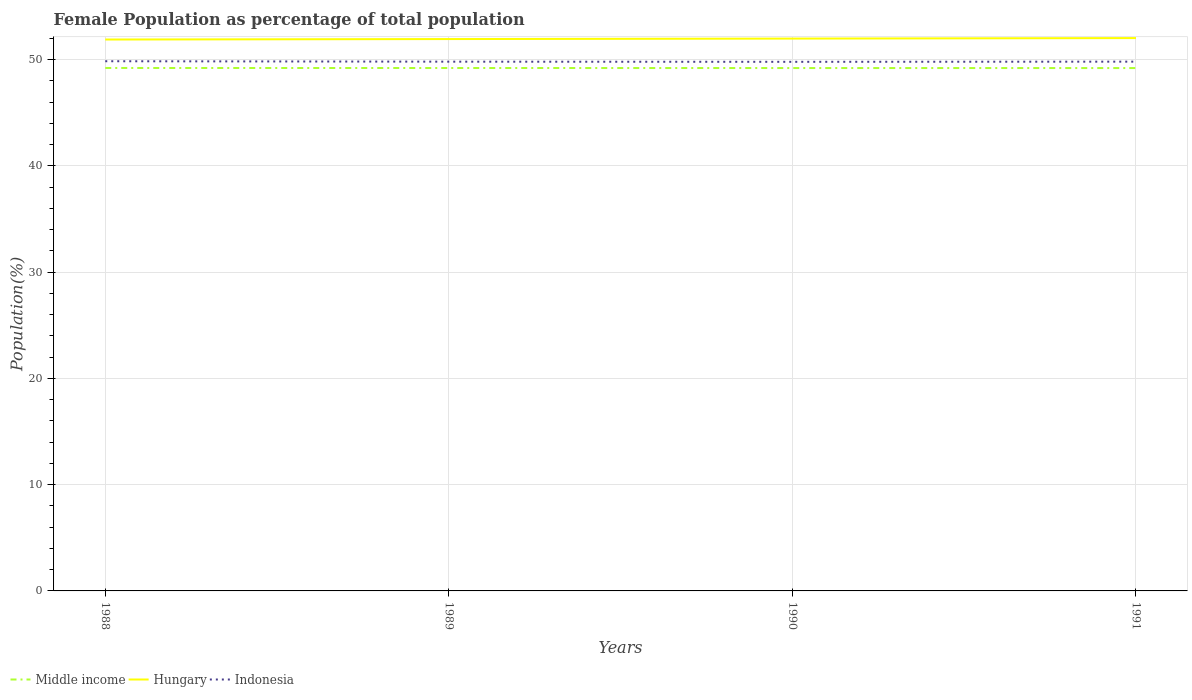Across all years, what is the maximum female population in in Indonesia?
Provide a succinct answer. 49.78. In which year was the female population in in Indonesia maximum?
Your answer should be very brief. 1990. What is the total female population in in Hungary in the graph?
Your response must be concise. -0.04. What is the difference between the highest and the second highest female population in in Middle income?
Your answer should be compact. 0.01. Is the female population in in Middle income strictly greater than the female population in in Indonesia over the years?
Your answer should be very brief. Yes. How many years are there in the graph?
Your answer should be very brief. 4. What is the difference between two consecutive major ticks on the Y-axis?
Keep it short and to the point. 10. Does the graph contain any zero values?
Offer a very short reply. No. What is the title of the graph?
Your response must be concise. Female Population as percentage of total population. Does "Belarus" appear as one of the legend labels in the graph?
Offer a very short reply. No. What is the label or title of the X-axis?
Ensure brevity in your answer.  Years. What is the label or title of the Y-axis?
Offer a very short reply. Population(%). What is the Population(%) of Middle income in 1988?
Provide a succinct answer. 49.2. What is the Population(%) in Hungary in 1988?
Offer a very short reply. 51.88. What is the Population(%) in Indonesia in 1988?
Make the answer very short. 49.84. What is the Population(%) in Middle income in 1989?
Offer a terse response. 49.2. What is the Population(%) in Hungary in 1989?
Offer a very short reply. 51.92. What is the Population(%) of Indonesia in 1989?
Provide a succinct answer. 49.8. What is the Population(%) of Middle income in 1990?
Provide a succinct answer. 49.2. What is the Population(%) in Hungary in 1990?
Keep it short and to the point. 51.97. What is the Population(%) of Indonesia in 1990?
Provide a short and direct response. 49.78. What is the Population(%) of Middle income in 1991?
Your answer should be very brief. 49.19. What is the Population(%) of Hungary in 1991?
Your answer should be very brief. 52.02. What is the Population(%) in Indonesia in 1991?
Give a very brief answer. 49.8. Across all years, what is the maximum Population(%) in Middle income?
Ensure brevity in your answer.  49.2. Across all years, what is the maximum Population(%) of Hungary?
Your answer should be compact. 52.02. Across all years, what is the maximum Population(%) in Indonesia?
Offer a terse response. 49.84. Across all years, what is the minimum Population(%) of Middle income?
Keep it short and to the point. 49.19. Across all years, what is the minimum Population(%) of Hungary?
Ensure brevity in your answer.  51.88. Across all years, what is the minimum Population(%) in Indonesia?
Make the answer very short. 49.78. What is the total Population(%) in Middle income in the graph?
Keep it short and to the point. 196.79. What is the total Population(%) of Hungary in the graph?
Keep it short and to the point. 207.78. What is the total Population(%) of Indonesia in the graph?
Your answer should be very brief. 199.21. What is the difference between the Population(%) of Middle income in 1988 and that in 1989?
Offer a very short reply. 0. What is the difference between the Population(%) of Hungary in 1988 and that in 1989?
Provide a short and direct response. -0.04. What is the difference between the Population(%) in Indonesia in 1988 and that in 1989?
Your answer should be compact. 0.04. What is the difference between the Population(%) in Middle income in 1988 and that in 1990?
Your answer should be very brief. 0.01. What is the difference between the Population(%) of Hungary in 1988 and that in 1990?
Ensure brevity in your answer.  -0.09. What is the difference between the Population(%) of Indonesia in 1988 and that in 1990?
Provide a succinct answer. 0.06. What is the difference between the Population(%) of Middle income in 1988 and that in 1991?
Offer a very short reply. 0.01. What is the difference between the Population(%) of Hungary in 1988 and that in 1991?
Your answer should be compact. -0.13. What is the difference between the Population(%) in Indonesia in 1988 and that in 1991?
Give a very brief answer. 0.04. What is the difference between the Population(%) of Middle income in 1989 and that in 1990?
Provide a succinct answer. 0. What is the difference between the Population(%) in Hungary in 1989 and that in 1990?
Ensure brevity in your answer.  -0.04. What is the difference between the Population(%) of Indonesia in 1989 and that in 1990?
Provide a succinct answer. 0.01. What is the difference between the Population(%) in Middle income in 1989 and that in 1991?
Make the answer very short. 0. What is the difference between the Population(%) in Hungary in 1989 and that in 1991?
Offer a terse response. -0.09. What is the difference between the Population(%) in Indonesia in 1989 and that in 1991?
Your answer should be compact. -0. What is the difference between the Population(%) of Middle income in 1990 and that in 1991?
Offer a terse response. 0. What is the difference between the Population(%) in Hungary in 1990 and that in 1991?
Your response must be concise. -0.05. What is the difference between the Population(%) in Indonesia in 1990 and that in 1991?
Make the answer very short. -0.02. What is the difference between the Population(%) of Middle income in 1988 and the Population(%) of Hungary in 1989?
Keep it short and to the point. -2.72. What is the difference between the Population(%) in Middle income in 1988 and the Population(%) in Indonesia in 1989?
Ensure brevity in your answer.  -0.59. What is the difference between the Population(%) in Hungary in 1988 and the Population(%) in Indonesia in 1989?
Your response must be concise. 2.09. What is the difference between the Population(%) of Middle income in 1988 and the Population(%) of Hungary in 1990?
Ensure brevity in your answer.  -2.76. What is the difference between the Population(%) of Middle income in 1988 and the Population(%) of Indonesia in 1990?
Provide a short and direct response. -0.58. What is the difference between the Population(%) of Hungary in 1988 and the Population(%) of Indonesia in 1990?
Your answer should be very brief. 2.1. What is the difference between the Population(%) in Middle income in 1988 and the Population(%) in Hungary in 1991?
Your answer should be compact. -2.81. What is the difference between the Population(%) of Middle income in 1988 and the Population(%) of Indonesia in 1991?
Your answer should be very brief. -0.6. What is the difference between the Population(%) of Hungary in 1988 and the Population(%) of Indonesia in 1991?
Offer a terse response. 2.08. What is the difference between the Population(%) of Middle income in 1989 and the Population(%) of Hungary in 1990?
Your response must be concise. -2.77. What is the difference between the Population(%) of Middle income in 1989 and the Population(%) of Indonesia in 1990?
Your answer should be very brief. -0.58. What is the difference between the Population(%) of Hungary in 1989 and the Population(%) of Indonesia in 1990?
Offer a very short reply. 2.14. What is the difference between the Population(%) in Middle income in 1989 and the Population(%) in Hungary in 1991?
Provide a succinct answer. -2.82. What is the difference between the Population(%) of Middle income in 1989 and the Population(%) of Indonesia in 1991?
Your answer should be very brief. -0.6. What is the difference between the Population(%) in Hungary in 1989 and the Population(%) in Indonesia in 1991?
Provide a short and direct response. 2.12. What is the difference between the Population(%) of Middle income in 1990 and the Population(%) of Hungary in 1991?
Offer a terse response. -2.82. What is the difference between the Population(%) of Middle income in 1990 and the Population(%) of Indonesia in 1991?
Ensure brevity in your answer.  -0.6. What is the difference between the Population(%) of Hungary in 1990 and the Population(%) of Indonesia in 1991?
Keep it short and to the point. 2.17. What is the average Population(%) in Middle income per year?
Offer a very short reply. 49.2. What is the average Population(%) in Hungary per year?
Ensure brevity in your answer.  51.95. What is the average Population(%) of Indonesia per year?
Provide a succinct answer. 49.8. In the year 1988, what is the difference between the Population(%) in Middle income and Population(%) in Hungary?
Your response must be concise. -2.68. In the year 1988, what is the difference between the Population(%) in Middle income and Population(%) in Indonesia?
Offer a terse response. -0.64. In the year 1988, what is the difference between the Population(%) of Hungary and Population(%) of Indonesia?
Your answer should be very brief. 2.04. In the year 1989, what is the difference between the Population(%) in Middle income and Population(%) in Hungary?
Your answer should be very brief. -2.72. In the year 1989, what is the difference between the Population(%) in Middle income and Population(%) in Indonesia?
Your answer should be compact. -0.6. In the year 1989, what is the difference between the Population(%) of Hungary and Population(%) of Indonesia?
Provide a succinct answer. 2.13. In the year 1990, what is the difference between the Population(%) of Middle income and Population(%) of Hungary?
Your answer should be compact. -2.77. In the year 1990, what is the difference between the Population(%) of Middle income and Population(%) of Indonesia?
Make the answer very short. -0.58. In the year 1990, what is the difference between the Population(%) of Hungary and Population(%) of Indonesia?
Offer a very short reply. 2.19. In the year 1991, what is the difference between the Population(%) of Middle income and Population(%) of Hungary?
Keep it short and to the point. -2.82. In the year 1991, what is the difference between the Population(%) in Middle income and Population(%) in Indonesia?
Give a very brief answer. -0.6. In the year 1991, what is the difference between the Population(%) in Hungary and Population(%) in Indonesia?
Keep it short and to the point. 2.22. What is the ratio of the Population(%) in Middle income in 1988 to that in 1989?
Your response must be concise. 1. What is the ratio of the Population(%) of Indonesia in 1988 to that in 1989?
Your answer should be very brief. 1. What is the ratio of the Population(%) in Hungary in 1988 to that in 1990?
Offer a terse response. 1. What is the ratio of the Population(%) in Hungary in 1988 to that in 1991?
Your answer should be compact. 1. What is the ratio of the Population(%) in Middle income in 1989 to that in 1990?
Keep it short and to the point. 1. What is the ratio of the Population(%) of Indonesia in 1989 to that in 1990?
Give a very brief answer. 1. What is the ratio of the Population(%) of Middle income in 1989 to that in 1991?
Make the answer very short. 1. What is the ratio of the Population(%) in Middle income in 1990 to that in 1991?
Offer a very short reply. 1. What is the difference between the highest and the second highest Population(%) of Middle income?
Ensure brevity in your answer.  0. What is the difference between the highest and the second highest Population(%) in Hungary?
Your answer should be very brief. 0.05. What is the difference between the highest and the second highest Population(%) in Indonesia?
Offer a very short reply. 0.04. What is the difference between the highest and the lowest Population(%) in Middle income?
Give a very brief answer. 0.01. What is the difference between the highest and the lowest Population(%) of Hungary?
Ensure brevity in your answer.  0.13. What is the difference between the highest and the lowest Population(%) of Indonesia?
Provide a succinct answer. 0.06. 